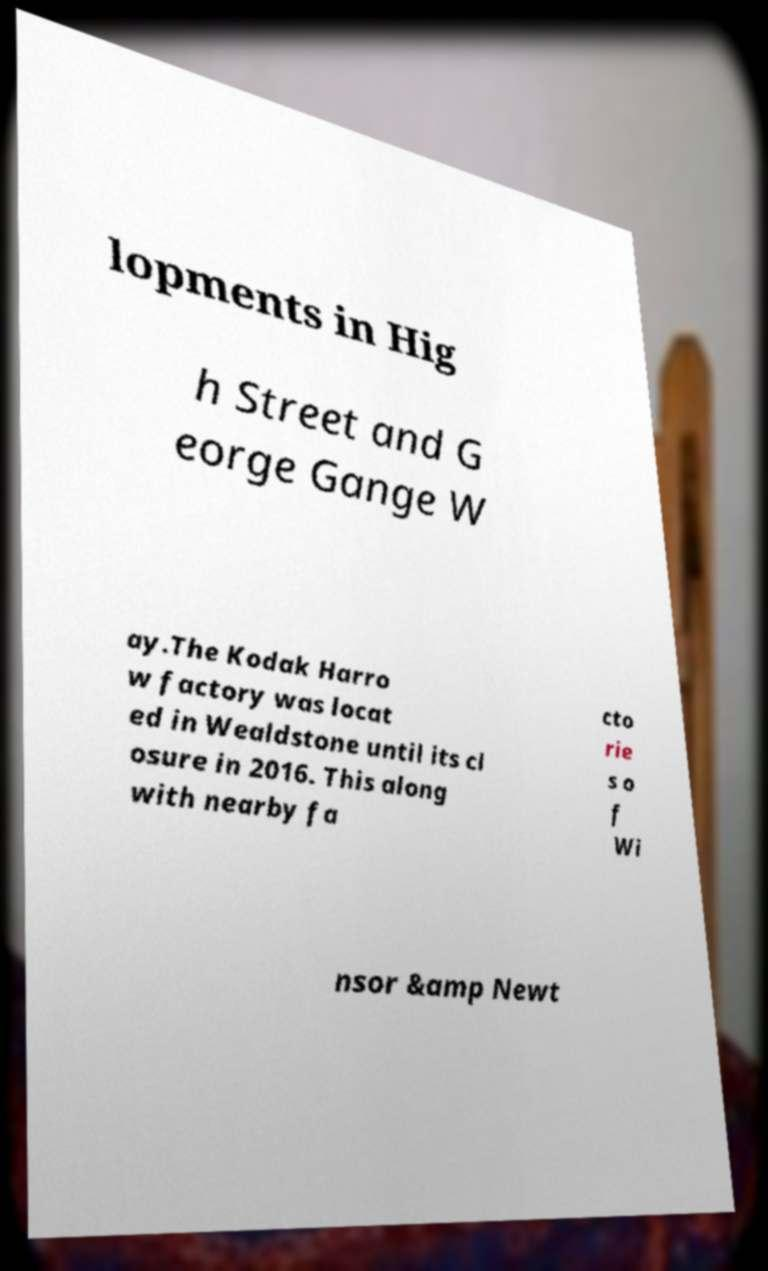Could you assist in decoding the text presented in this image and type it out clearly? lopments in Hig h Street and G eorge Gange W ay.The Kodak Harro w factory was locat ed in Wealdstone until its cl osure in 2016. This along with nearby fa cto rie s o f Wi nsor &amp Newt 